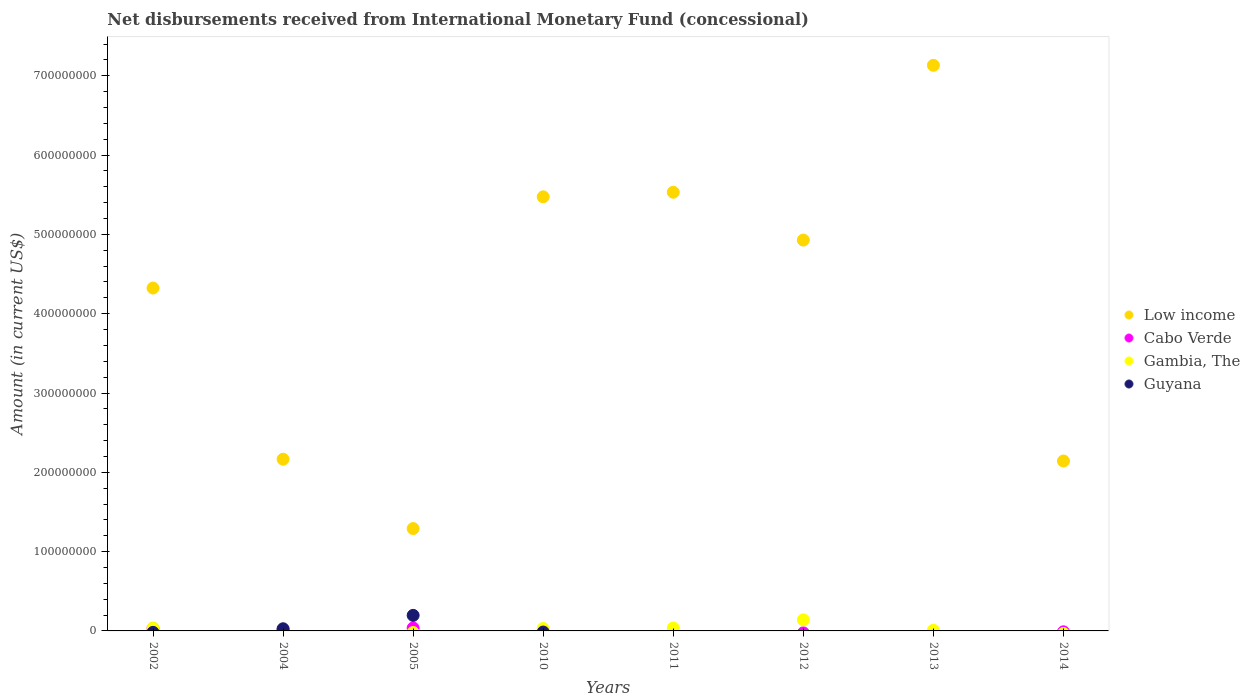What is the amount of disbursements received from International Monetary Fund in Low income in 2011?
Your response must be concise. 5.53e+08. Across all years, what is the maximum amount of disbursements received from International Monetary Fund in Gambia, The?
Provide a succinct answer. 1.39e+07. Across all years, what is the minimum amount of disbursements received from International Monetary Fund in Low income?
Provide a short and direct response. 1.29e+08. What is the total amount of disbursements received from International Monetary Fund in Low income in the graph?
Give a very brief answer. 3.30e+09. What is the difference between the amount of disbursements received from International Monetary Fund in Gambia, The in 2011 and that in 2012?
Your response must be concise. -1.03e+07. What is the difference between the amount of disbursements received from International Monetary Fund in Low income in 2005 and the amount of disbursements received from International Monetary Fund in Gambia, The in 2012?
Offer a terse response. 1.15e+08. What is the average amount of disbursements received from International Monetary Fund in Gambia, The per year?
Offer a very short reply. 3.16e+06. In the year 2005, what is the difference between the amount of disbursements received from International Monetary Fund in Low income and amount of disbursements received from International Monetary Fund in Cabo Verde?
Your response must be concise. 1.25e+08. What is the ratio of the amount of disbursements received from International Monetary Fund in Low income in 2002 to that in 2004?
Offer a very short reply. 2. Is the amount of disbursements received from International Monetary Fund in Low income in 2002 less than that in 2004?
Give a very brief answer. No. What is the difference between the highest and the second highest amount of disbursements received from International Monetary Fund in Cabo Verde?
Your answer should be compact. 4.94e+05. What is the difference between the highest and the lowest amount of disbursements received from International Monetary Fund in Low income?
Make the answer very short. 5.84e+08. In how many years, is the amount of disbursements received from International Monetary Fund in Low income greater than the average amount of disbursements received from International Monetary Fund in Low income taken over all years?
Keep it short and to the point. 5. Is the sum of the amount of disbursements received from International Monetary Fund in Low income in 2011 and 2014 greater than the maximum amount of disbursements received from International Monetary Fund in Cabo Verde across all years?
Give a very brief answer. Yes. Is it the case that in every year, the sum of the amount of disbursements received from International Monetary Fund in Cabo Verde and amount of disbursements received from International Monetary Fund in Guyana  is greater than the sum of amount of disbursements received from International Monetary Fund in Gambia, The and amount of disbursements received from International Monetary Fund in Low income?
Give a very brief answer. No. Is it the case that in every year, the sum of the amount of disbursements received from International Monetary Fund in Gambia, The and amount of disbursements received from International Monetary Fund in Cabo Verde  is greater than the amount of disbursements received from International Monetary Fund in Guyana?
Provide a short and direct response. No. How many dotlines are there?
Provide a short and direct response. 4. How many years are there in the graph?
Keep it short and to the point. 8. What is the difference between two consecutive major ticks on the Y-axis?
Keep it short and to the point. 1.00e+08. Are the values on the major ticks of Y-axis written in scientific E-notation?
Ensure brevity in your answer.  No. Does the graph contain any zero values?
Offer a very short reply. Yes. How are the legend labels stacked?
Provide a succinct answer. Vertical. What is the title of the graph?
Provide a short and direct response. Net disbursements received from International Monetary Fund (concessional). Does "Denmark" appear as one of the legend labels in the graph?
Keep it short and to the point. No. What is the label or title of the Y-axis?
Your response must be concise. Amount (in current US$). What is the Amount (in current US$) of Low income in 2002?
Ensure brevity in your answer.  4.32e+08. What is the Amount (in current US$) in Cabo Verde in 2002?
Ensure brevity in your answer.  3.18e+06. What is the Amount (in current US$) in Gambia, The in 2002?
Ensure brevity in your answer.  3.74e+06. What is the Amount (in current US$) in Guyana in 2002?
Give a very brief answer. 0. What is the Amount (in current US$) of Low income in 2004?
Offer a very short reply. 2.17e+08. What is the Amount (in current US$) of Cabo Verde in 2004?
Provide a succinct answer. 1.82e+06. What is the Amount (in current US$) of Gambia, The in 2004?
Offer a very short reply. 0. What is the Amount (in current US$) in Guyana in 2004?
Make the answer very short. 2.72e+06. What is the Amount (in current US$) of Low income in 2005?
Ensure brevity in your answer.  1.29e+08. What is the Amount (in current US$) of Cabo Verde in 2005?
Ensure brevity in your answer.  3.68e+06. What is the Amount (in current US$) in Guyana in 2005?
Give a very brief answer. 1.96e+07. What is the Amount (in current US$) of Low income in 2010?
Make the answer very short. 5.47e+08. What is the Amount (in current US$) in Gambia, The in 2010?
Your answer should be compact. 3.04e+06. What is the Amount (in current US$) in Guyana in 2010?
Offer a very short reply. 0. What is the Amount (in current US$) of Low income in 2011?
Your response must be concise. 5.53e+08. What is the Amount (in current US$) of Gambia, The in 2011?
Make the answer very short. 3.68e+06. What is the Amount (in current US$) in Guyana in 2011?
Offer a very short reply. 0. What is the Amount (in current US$) of Low income in 2012?
Offer a very short reply. 4.93e+08. What is the Amount (in current US$) of Gambia, The in 2012?
Offer a terse response. 1.39e+07. What is the Amount (in current US$) in Low income in 2013?
Ensure brevity in your answer.  7.13e+08. What is the Amount (in current US$) in Gambia, The in 2013?
Provide a succinct answer. 8.47e+05. What is the Amount (in current US$) of Low income in 2014?
Offer a terse response. 2.14e+08. What is the Amount (in current US$) in Guyana in 2014?
Provide a short and direct response. 0. Across all years, what is the maximum Amount (in current US$) of Low income?
Keep it short and to the point. 7.13e+08. Across all years, what is the maximum Amount (in current US$) of Cabo Verde?
Provide a succinct answer. 3.68e+06. Across all years, what is the maximum Amount (in current US$) of Gambia, The?
Give a very brief answer. 1.39e+07. Across all years, what is the maximum Amount (in current US$) in Guyana?
Make the answer very short. 1.96e+07. Across all years, what is the minimum Amount (in current US$) of Low income?
Provide a succinct answer. 1.29e+08. Across all years, what is the minimum Amount (in current US$) in Cabo Verde?
Provide a short and direct response. 0. Across all years, what is the minimum Amount (in current US$) in Gambia, The?
Your response must be concise. 0. What is the total Amount (in current US$) of Low income in the graph?
Offer a terse response. 3.30e+09. What is the total Amount (in current US$) in Cabo Verde in the graph?
Provide a short and direct response. 8.69e+06. What is the total Amount (in current US$) in Gambia, The in the graph?
Keep it short and to the point. 2.53e+07. What is the total Amount (in current US$) in Guyana in the graph?
Keep it short and to the point. 2.23e+07. What is the difference between the Amount (in current US$) of Low income in 2002 and that in 2004?
Ensure brevity in your answer.  2.16e+08. What is the difference between the Amount (in current US$) of Cabo Verde in 2002 and that in 2004?
Provide a succinct answer. 1.36e+06. What is the difference between the Amount (in current US$) in Low income in 2002 and that in 2005?
Provide a succinct answer. 3.03e+08. What is the difference between the Amount (in current US$) in Cabo Verde in 2002 and that in 2005?
Offer a terse response. -4.94e+05. What is the difference between the Amount (in current US$) of Low income in 2002 and that in 2010?
Keep it short and to the point. -1.15e+08. What is the difference between the Amount (in current US$) of Gambia, The in 2002 and that in 2010?
Make the answer very short. 6.98e+05. What is the difference between the Amount (in current US$) in Low income in 2002 and that in 2011?
Your response must be concise. -1.21e+08. What is the difference between the Amount (in current US$) in Gambia, The in 2002 and that in 2011?
Make the answer very short. 6.30e+04. What is the difference between the Amount (in current US$) in Low income in 2002 and that in 2012?
Your response must be concise. -6.05e+07. What is the difference between the Amount (in current US$) in Gambia, The in 2002 and that in 2012?
Give a very brief answer. -1.02e+07. What is the difference between the Amount (in current US$) in Low income in 2002 and that in 2013?
Your answer should be very brief. -2.81e+08. What is the difference between the Amount (in current US$) of Gambia, The in 2002 and that in 2013?
Make the answer very short. 2.90e+06. What is the difference between the Amount (in current US$) of Low income in 2002 and that in 2014?
Make the answer very short. 2.18e+08. What is the difference between the Amount (in current US$) of Low income in 2004 and that in 2005?
Give a very brief answer. 8.74e+07. What is the difference between the Amount (in current US$) in Cabo Verde in 2004 and that in 2005?
Offer a terse response. -1.86e+06. What is the difference between the Amount (in current US$) in Guyana in 2004 and that in 2005?
Make the answer very short. -1.69e+07. What is the difference between the Amount (in current US$) of Low income in 2004 and that in 2010?
Keep it short and to the point. -3.31e+08. What is the difference between the Amount (in current US$) in Low income in 2004 and that in 2011?
Offer a terse response. -3.37e+08. What is the difference between the Amount (in current US$) in Low income in 2004 and that in 2012?
Keep it short and to the point. -2.76e+08. What is the difference between the Amount (in current US$) in Low income in 2004 and that in 2013?
Provide a short and direct response. -4.97e+08. What is the difference between the Amount (in current US$) in Low income in 2004 and that in 2014?
Your answer should be very brief. 2.22e+06. What is the difference between the Amount (in current US$) in Low income in 2005 and that in 2010?
Offer a terse response. -4.18e+08. What is the difference between the Amount (in current US$) of Low income in 2005 and that in 2011?
Offer a very short reply. -4.24e+08. What is the difference between the Amount (in current US$) of Low income in 2005 and that in 2012?
Your answer should be compact. -3.64e+08. What is the difference between the Amount (in current US$) in Low income in 2005 and that in 2013?
Your answer should be compact. -5.84e+08. What is the difference between the Amount (in current US$) of Low income in 2005 and that in 2014?
Your response must be concise. -8.52e+07. What is the difference between the Amount (in current US$) in Low income in 2010 and that in 2011?
Ensure brevity in your answer.  -5.76e+06. What is the difference between the Amount (in current US$) in Gambia, The in 2010 and that in 2011?
Provide a succinct answer. -6.35e+05. What is the difference between the Amount (in current US$) of Low income in 2010 and that in 2012?
Give a very brief answer. 5.45e+07. What is the difference between the Amount (in current US$) of Gambia, The in 2010 and that in 2012?
Give a very brief answer. -1.09e+07. What is the difference between the Amount (in current US$) in Low income in 2010 and that in 2013?
Ensure brevity in your answer.  -1.66e+08. What is the difference between the Amount (in current US$) of Gambia, The in 2010 and that in 2013?
Your answer should be compact. 2.20e+06. What is the difference between the Amount (in current US$) of Low income in 2010 and that in 2014?
Make the answer very short. 3.33e+08. What is the difference between the Amount (in current US$) in Low income in 2011 and that in 2012?
Your response must be concise. 6.03e+07. What is the difference between the Amount (in current US$) of Gambia, The in 2011 and that in 2012?
Provide a short and direct response. -1.03e+07. What is the difference between the Amount (in current US$) of Low income in 2011 and that in 2013?
Make the answer very short. -1.60e+08. What is the difference between the Amount (in current US$) of Gambia, The in 2011 and that in 2013?
Your response must be concise. 2.83e+06. What is the difference between the Amount (in current US$) of Low income in 2011 and that in 2014?
Your response must be concise. 3.39e+08. What is the difference between the Amount (in current US$) in Low income in 2012 and that in 2013?
Provide a short and direct response. -2.20e+08. What is the difference between the Amount (in current US$) of Gambia, The in 2012 and that in 2013?
Your response must be concise. 1.31e+07. What is the difference between the Amount (in current US$) of Low income in 2012 and that in 2014?
Give a very brief answer. 2.79e+08. What is the difference between the Amount (in current US$) in Low income in 2013 and that in 2014?
Ensure brevity in your answer.  4.99e+08. What is the difference between the Amount (in current US$) of Low income in 2002 and the Amount (in current US$) of Cabo Verde in 2004?
Your response must be concise. 4.31e+08. What is the difference between the Amount (in current US$) in Low income in 2002 and the Amount (in current US$) in Guyana in 2004?
Offer a very short reply. 4.30e+08. What is the difference between the Amount (in current US$) of Cabo Verde in 2002 and the Amount (in current US$) of Guyana in 2004?
Your answer should be compact. 4.70e+05. What is the difference between the Amount (in current US$) in Gambia, The in 2002 and the Amount (in current US$) in Guyana in 2004?
Give a very brief answer. 1.03e+06. What is the difference between the Amount (in current US$) in Low income in 2002 and the Amount (in current US$) in Cabo Verde in 2005?
Offer a terse response. 4.29e+08. What is the difference between the Amount (in current US$) in Low income in 2002 and the Amount (in current US$) in Guyana in 2005?
Ensure brevity in your answer.  4.13e+08. What is the difference between the Amount (in current US$) of Cabo Verde in 2002 and the Amount (in current US$) of Guyana in 2005?
Offer a terse response. -1.64e+07. What is the difference between the Amount (in current US$) of Gambia, The in 2002 and the Amount (in current US$) of Guyana in 2005?
Ensure brevity in your answer.  -1.59e+07. What is the difference between the Amount (in current US$) of Low income in 2002 and the Amount (in current US$) of Gambia, The in 2010?
Make the answer very short. 4.29e+08. What is the difference between the Amount (in current US$) in Cabo Verde in 2002 and the Amount (in current US$) in Gambia, The in 2010?
Make the answer very short. 1.41e+05. What is the difference between the Amount (in current US$) in Low income in 2002 and the Amount (in current US$) in Gambia, The in 2011?
Your response must be concise. 4.29e+08. What is the difference between the Amount (in current US$) in Cabo Verde in 2002 and the Amount (in current US$) in Gambia, The in 2011?
Offer a very short reply. -4.94e+05. What is the difference between the Amount (in current US$) in Low income in 2002 and the Amount (in current US$) in Gambia, The in 2012?
Give a very brief answer. 4.18e+08. What is the difference between the Amount (in current US$) in Cabo Verde in 2002 and the Amount (in current US$) in Gambia, The in 2012?
Provide a short and direct response. -1.08e+07. What is the difference between the Amount (in current US$) of Low income in 2002 and the Amount (in current US$) of Gambia, The in 2013?
Provide a short and direct response. 4.31e+08. What is the difference between the Amount (in current US$) of Cabo Verde in 2002 and the Amount (in current US$) of Gambia, The in 2013?
Make the answer very short. 2.34e+06. What is the difference between the Amount (in current US$) in Low income in 2004 and the Amount (in current US$) in Cabo Verde in 2005?
Your answer should be very brief. 2.13e+08. What is the difference between the Amount (in current US$) in Low income in 2004 and the Amount (in current US$) in Guyana in 2005?
Make the answer very short. 1.97e+08. What is the difference between the Amount (in current US$) in Cabo Verde in 2004 and the Amount (in current US$) in Guyana in 2005?
Give a very brief answer. -1.78e+07. What is the difference between the Amount (in current US$) in Low income in 2004 and the Amount (in current US$) in Gambia, The in 2010?
Offer a terse response. 2.13e+08. What is the difference between the Amount (in current US$) of Cabo Verde in 2004 and the Amount (in current US$) of Gambia, The in 2010?
Your answer should be compact. -1.22e+06. What is the difference between the Amount (in current US$) in Low income in 2004 and the Amount (in current US$) in Gambia, The in 2011?
Your response must be concise. 2.13e+08. What is the difference between the Amount (in current US$) of Cabo Verde in 2004 and the Amount (in current US$) of Gambia, The in 2011?
Give a very brief answer. -1.86e+06. What is the difference between the Amount (in current US$) in Low income in 2004 and the Amount (in current US$) in Gambia, The in 2012?
Your response must be concise. 2.03e+08. What is the difference between the Amount (in current US$) of Cabo Verde in 2004 and the Amount (in current US$) of Gambia, The in 2012?
Your answer should be very brief. -1.21e+07. What is the difference between the Amount (in current US$) of Low income in 2004 and the Amount (in current US$) of Gambia, The in 2013?
Keep it short and to the point. 2.16e+08. What is the difference between the Amount (in current US$) of Cabo Verde in 2004 and the Amount (in current US$) of Gambia, The in 2013?
Your response must be concise. 9.76e+05. What is the difference between the Amount (in current US$) in Low income in 2005 and the Amount (in current US$) in Gambia, The in 2010?
Give a very brief answer. 1.26e+08. What is the difference between the Amount (in current US$) of Cabo Verde in 2005 and the Amount (in current US$) of Gambia, The in 2010?
Your response must be concise. 6.35e+05. What is the difference between the Amount (in current US$) of Low income in 2005 and the Amount (in current US$) of Gambia, The in 2011?
Keep it short and to the point. 1.25e+08. What is the difference between the Amount (in current US$) in Low income in 2005 and the Amount (in current US$) in Gambia, The in 2012?
Ensure brevity in your answer.  1.15e+08. What is the difference between the Amount (in current US$) of Cabo Verde in 2005 and the Amount (in current US$) of Gambia, The in 2012?
Your response must be concise. -1.03e+07. What is the difference between the Amount (in current US$) in Low income in 2005 and the Amount (in current US$) in Gambia, The in 2013?
Provide a short and direct response. 1.28e+08. What is the difference between the Amount (in current US$) in Cabo Verde in 2005 and the Amount (in current US$) in Gambia, The in 2013?
Provide a succinct answer. 2.83e+06. What is the difference between the Amount (in current US$) of Low income in 2010 and the Amount (in current US$) of Gambia, The in 2011?
Keep it short and to the point. 5.44e+08. What is the difference between the Amount (in current US$) in Low income in 2010 and the Amount (in current US$) in Gambia, The in 2012?
Give a very brief answer. 5.33e+08. What is the difference between the Amount (in current US$) in Low income in 2010 and the Amount (in current US$) in Gambia, The in 2013?
Ensure brevity in your answer.  5.47e+08. What is the difference between the Amount (in current US$) of Low income in 2011 and the Amount (in current US$) of Gambia, The in 2012?
Ensure brevity in your answer.  5.39e+08. What is the difference between the Amount (in current US$) in Low income in 2011 and the Amount (in current US$) in Gambia, The in 2013?
Ensure brevity in your answer.  5.52e+08. What is the difference between the Amount (in current US$) of Low income in 2012 and the Amount (in current US$) of Gambia, The in 2013?
Offer a very short reply. 4.92e+08. What is the average Amount (in current US$) in Low income per year?
Keep it short and to the point. 4.12e+08. What is the average Amount (in current US$) in Cabo Verde per year?
Keep it short and to the point. 1.09e+06. What is the average Amount (in current US$) of Gambia, The per year?
Provide a short and direct response. 3.16e+06. What is the average Amount (in current US$) in Guyana per year?
Make the answer very short. 2.79e+06. In the year 2002, what is the difference between the Amount (in current US$) of Low income and Amount (in current US$) of Cabo Verde?
Make the answer very short. 4.29e+08. In the year 2002, what is the difference between the Amount (in current US$) of Low income and Amount (in current US$) of Gambia, The?
Keep it short and to the point. 4.29e+08. In the year 2002, what is the difference between the Amount (in current US$) of Cabo Verde and Amount (in current US$) of Gambia, The?
Ensure brevity in your answer.  -5.57e+05. In the year 2004, what is the difference between the Amount (in current US$) in Low income and Amount (in current US$) in Cabo Verde?
Keep it short and to the point. 2.15e+08. In the year 2004, what is the difference between the Amount (in current US$) of Low income and Amount (in current US$) of Guyana?
Your answer should be very brief. 2.14e+08. In the year 2004, what is the difference between the Amount (in current US$) of Cabo Verde and Amount (in current US$) of Guyana?
Provide a succinct answer. -8.92e+05. In the year 2005, what is the difference between the Amount (in current US$) in Low income and Amount (in current US$) in Cabo Verde?
Give a very brief answer. 1.25e+08. In the year 2005, what is the difference between the Amount (in current US$) in Low income and Amount (in current US$) in Guyana?
Provide a short and direct response. 1.09e+08. In the year 2005, what is the difference between the Amount (in current US$) in Cabo Verde and Amount (in current US$) in Guyana?
Your answer should be compact. -1.59e+07. In the year 2010, what is the difference between the Amount (in current US$) of Low income and Amount (in current US$) of Gambia, The?
Your answer should be very brief. 5.44e+08. In the year 2011, what is the difference between the Amount (in current US$) of Low income and Amount (in current US$) of Gambia, The?
Your response must be concise. 5.49e+08. In the year 2012, what is the difference between the Amount (in current US$) in Low income and Amount (in current US$) in Gambia, The?
Give a very brief answer. 4.79e+08. In the year 2013, what is the difference between the Amount (in current US$) in Low income and Amount (in current US$) in Gambia, The?
Offer a terse response. 7.12e+08. What is the ratio of the Amount (in current US$) in Low income in 2002 to that in 2004?
Provide a short and direct response. 2. What is the ratio of the Amount (in current US$) of Cabo Verde in 2002 to that in 2004?
Your response must be concise. 1.75. What is the ratio of the Amount (in current US$) in Low income in 2002 to that in 2005?
Give a very brief answer. 3.35. What is the ratio of the Amount (in current US$) in Cabo Verde in 2002 to that in 2005?
Your answer should be very brief. 0.87. What is the ratio of the Amount (in current US$) of Low income in 2002 to that in 2010?
Your answer should be compact. 0.79. What is the ratio of the Amount (in current US$) in Gambia, The in 2002 to that in 2010?
Give a very brief answer. 1.23. What is the ratio of the Amount (in current US$) in Low income in 2002 to that in 2011?
Give a very brief answer. 0.78. What is the ratio of the Amount (in current US$) of Gambia, The in 2002 to that in 2011?
Ensure brevity in your answer.  1.02. What is the ratio of the Amount (in current US$) in Low income in 2002 to that in 2012?
Give a very brief answer. 0.88. What is the ratio of the Amount (in current US$) in Gambia, The in 2002 to that in 2012?
Give a very brief answer. 0.27. What is the ratio of the Amount (in current US$) in Low income in 2002 to that in 2013?
Your response must be concise. 0.61. What is the ratio of the Amount (in current US$) of Gambia, The in 2002 to that in 2013?
Keep it short and to the point. 4.42. What is the ratio of the Amount (in current US$) in Low income in 2002 to that in 2014?
Offer a very short reply. 2.02. What is the ratio of the Amount (in current US$) in Low income in 2004 to that in 2005?
Provide a succinct answer. 1.68. What is the ratio of the Amount (in current US$) of Cabo Verde in 2004 to that in 2005?
Ensure brevity in your answer.  0.5. What is the ratio of the Amount (in current US$) in Guyana in 2004 to that in 2005?
Your answer should be compact. 0.14. What is the ratio of the Amount (in current US$) in Low income in 2004 to that in 2010?
Provide a succinct answer. 0.4. What is the ratio of the Amount (in current US$) in Low income in 2004 to that in 2011?
Offer a very short reply. 0.39. What is the ratio of the Amount (in current US$) of Low income in 2004 to that in 2012?
Your answer should be compact. 0.44. What is the ratio of the Amount (in current US$) of Low income in 2004 to that in 2013?
Offer a terse response. 0.3. What is the ratio of the Amount (in current US$) of Low income in 2004 to that in 2014?
Offer a very short reply. 1.01. What is the ratio of the Amount (in current US$) in Low income in 2005 to that in 2010?
Provide a succinct answer. 0.24. What is the ratio of the Amount (in current US$) in Low income in 2005 to that in 2011?
Provide a short and direct response. 0.23. What is the ratio of the Amount (in current US$) of Low income in 2005 to that in 2012?
Your answer should be very brief. 0.26. What is the ratio of the Amount (in current US$) in Low income in 2005 to that in 2013?
Provide a short and direct response. 0.18. What is the ratio of the Amount (in current US$) in Low income in 2005 to that in 2014?
Provide a succinct answer. 0.6. What is the ratio of the Amount (in current US$) of Gambia, The in 2010 to that in 2011?
Provide a short and direct response. 0.83. What is the ratio of the Amount (in current US$) of Low income in 2010 to that in 2012?
Make the answer very short. 1.11. What is the ratio of the Amount (in current US$) in Gambia, The in 2010 to that in 2012?
Offer a terse response. 0.22. What is the ratio of the Amount (in current US$) in Low income in 2010 to that in 2013?
Offer a terse response. 0.77. What is the ratio of the Amount (in current US$) of Gambia, The in 2010 to that in 2013?
Keep it short and to the point. 3.59. What is the ratio of the Amount (in current US$) of Low income in 2010 to that in 2014?
Your response must be concise. 2.55. What is the ratio of the Amount (in current US$) in Low income in 2011 to that in 2012?
Your answer should be compact. 1.12. What is the ratio of the Amount (in current US$) in Gambia, The in 2011 to that in 2012?
Offer a terse response. 0.26. What is the ratio of the Amount (in current US$) of Low income in 2011 to that in 2013?
Keep it short and to the point. 0.78. What is the ratio of the Amount (in current US$) in Gambia, The in 2011 to that in 2013?
Ensure brevity in your answer.  4.34. What is the ratio of the Amount (in current US$) in Low income in 2011 to that in 2014?
Make the answer very short. 2.58. What is the ratio of the Amount (in current US$) in Low income in 2012 to that in 2013?
Give a very brief answer. 0.69. What is the ratio of the Amount (in current US$) of Gambia, The in 2012 to that in 2013?
Provide a short and direct response. 16.47. What is the ratio of the Amount (in current US$) of Low income in 2012 to that in 2014?
Provide a succinct answer. 2.3. What is the ratio of the Amount (in current US$) of Low income in 2013 to that in 2014?
Keep it short and to the point. 3.33. What is the difference between the highest and the second highest Amount (in current US$) in Low income?
Your response must be concise. 1.60e+08. What is the difference between the highest and the second highest Amount (in current US$) in Cabo Verde?
Your response must be concise. 4.94e+05. What is the difference between the highest and the second highest Amount (in current US$) of Gambia, The?
Your response must be concise. 1.02e+07. What is the difference between the highest and the lowest Amount (in current US$) in Low income?
Offer a very short reply. 5.84e+08. What is the difference between the highest and the lowest Amount (in current US$) of Cabo Verde?
Your response must be concise. 3.68e+06. What is the difference between the highest and the lowest Amount (in current US$) in Gambia, The?
Your answer should be compact. 1.39e+07. What is the difference between the highest and the lowest Amount (in current US$) in Guyana?
Make the answer very short. 1.96e+07. 